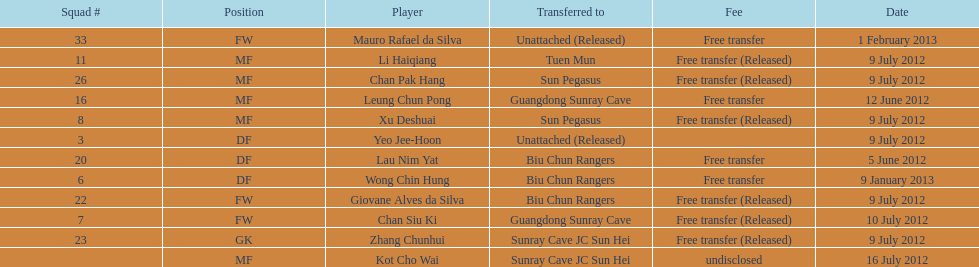Which players played during the 2012-13 south china aa season? Lau Nim Yat, Leung Chun Pong, Yeo Jee-Hoon, Xu Deshuai, Li Haiqiang, Giovane Alves da Silva, Zhang Chunhui, Chan Pak Hang, Chan Siu Ki, Kot Cho Wai, Wong Chin Hung, Mauro Rafael da Silva. Of these, which were free transfers that were not released? Lau Nim Yat, Leung Chun Pong, Wong Chin Hung, Mauro Rafael da Silva. Of these, which were in squad # 6? Wong Chin Hung. What was the date of his transfer? 9 January 2013. 